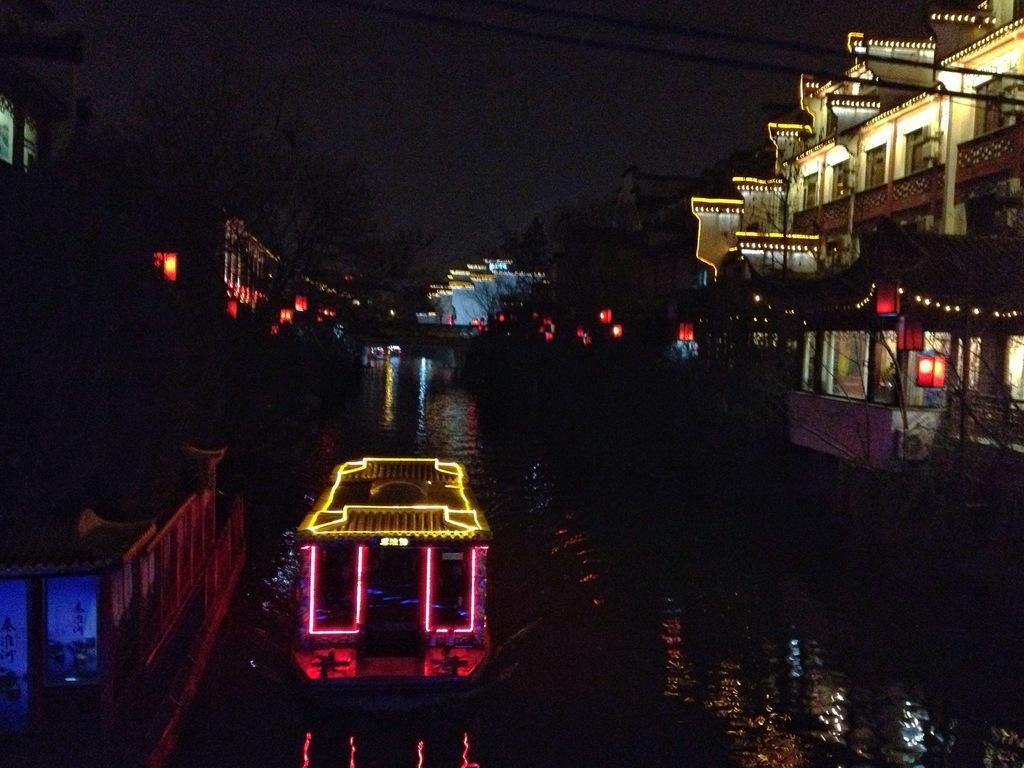Can you describe this image briefly? In this picture we can see water at the bottom, there is a boat here, we can see a building on the right side, there are some trees and lights in the background, we can see a wire here. 